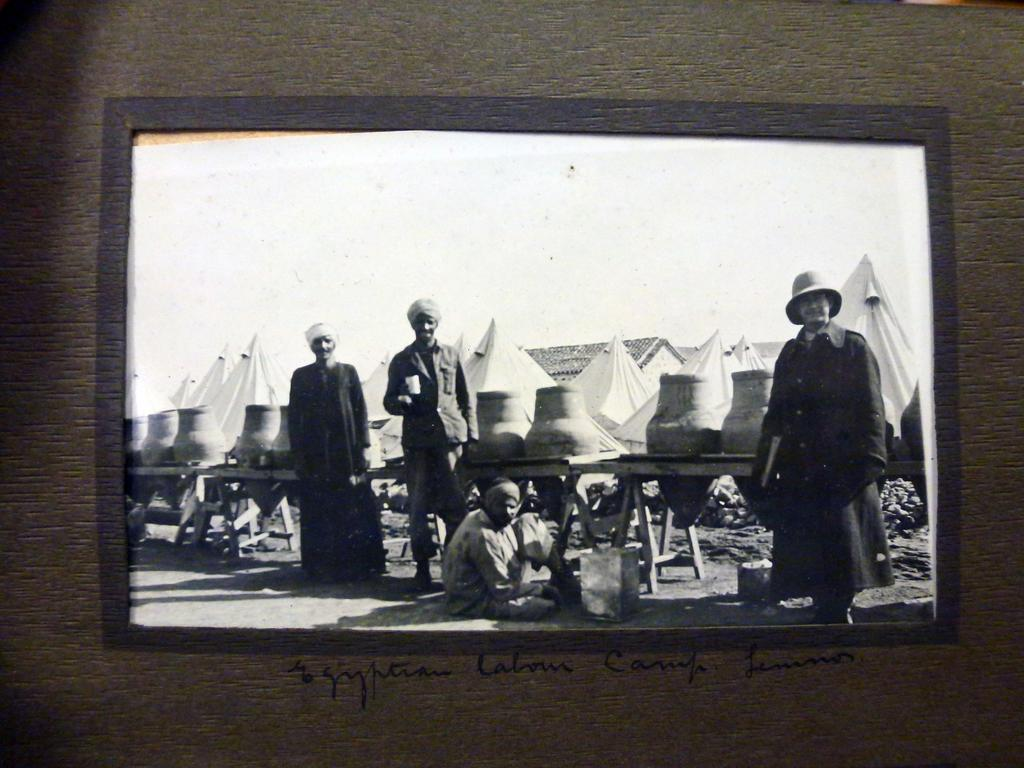What is the color scheme of the frame in the image? The frame in the image is black and white. Who or what can be seen in the image? There are people in the image. What type of structures are present in the image? There are sheds and benches in the image. What is at the bottom of the image? There is a road at the bottom of the image. Is there any text visible in the image? Yes, there is some text visible in the image. What type of berry is growing on the wing of the airplane in the image? There is no airplane or berry present in the image. 